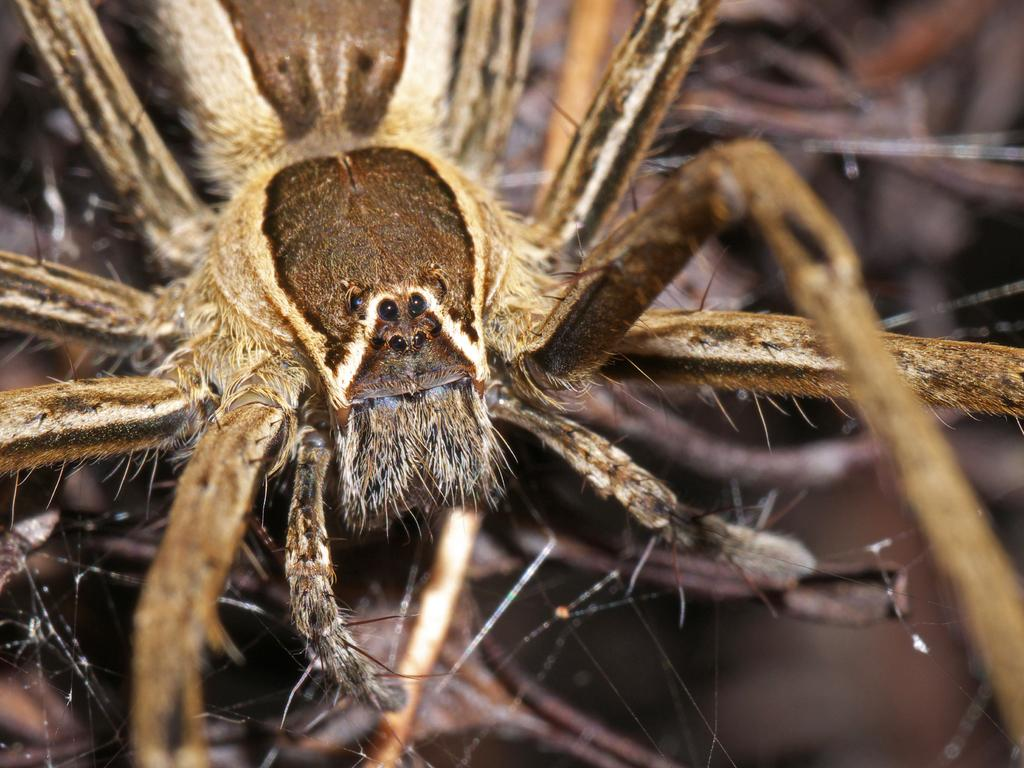What is the main subject of the image? The main subject of the image is a spider. Can you describe the appearance of the spider? The spider has a brown and cream color. Is there a rat in the image? No, there is no rat present in the image; the main subject is a spider. Can you tell me how many cacti are in the image? There is no mention of cacti in the provided facts, so it cannot be determined if any are present in the image. 